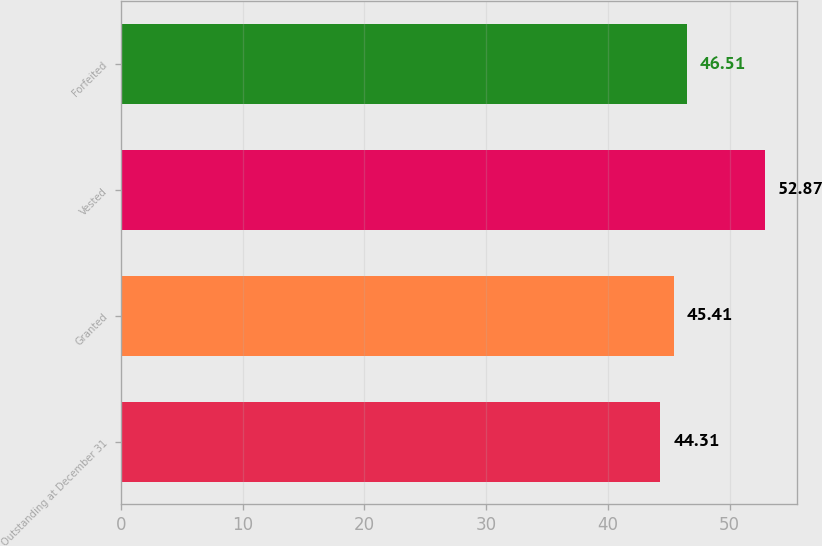<chart> <loc_0><loc_0><loc_500><loc_500><bar_chart><fcel>Outstanding at December 31<fcel>Granted<fcel>Vested<fcel>Forfeited<nl><fcel>44.31<fcel>45.41<fcel>52.87<fcel>46.51<nl></chart> 